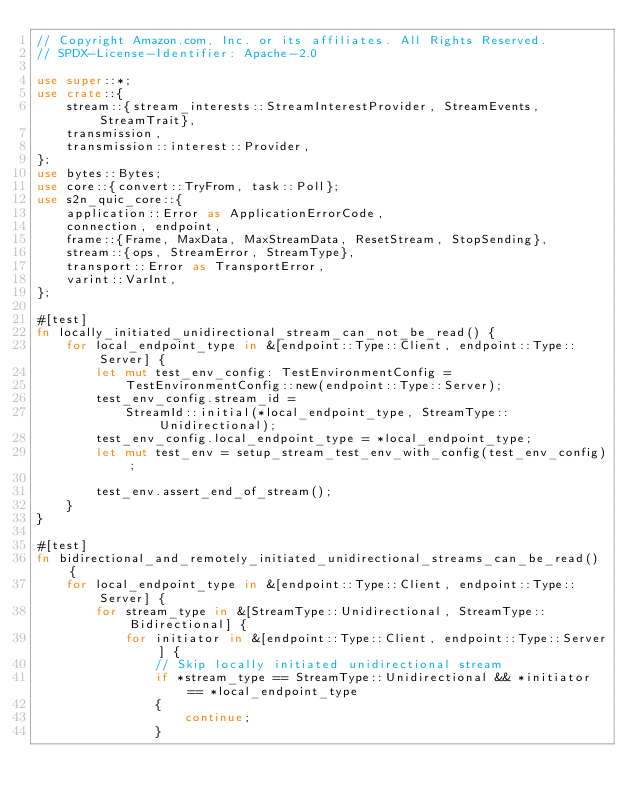<code> <loc_0><loc_0><loc_500><loc_500><_Rust_>// Copyright Amazon.com, Inc. or its affiliates. All Rights Reserved.
// SPDX-License-Identifier: Apache-2.0

use super::*;
use crate::{
    stream::{stream_interests::StreamInterestProvider, StreamEvents, StreamTrait},
    transmission,
    transmission::interest::Provider,
};
use bytes::Bytes;
use core::{convert::TryFrom, task::Poll};
use s2n_quic_core::{
    application::Error as ApplicationErrorCode,
    connection, endpoint,
    frame::{Frame, MaxData, MaxStreamData, ResetStream, StopSending},
    stream::{ops, StreamError, StreamType},
    transport::Error as TransportError,
    varint::VarInt,
};

#[test]
fn locally_initiated_unidirectional_stream_can_not_be_read() {
    for local_endpoint_type in &[endpoint::Type::Client, endpoint::Type::Server] {
        let mut test_env_config: TestEnvironmentConfig =
            TestEnvironmentConfig::new(endpoint::Type::Server);
        test_env_config.stream_id =
            StreamId::initial(*local_endpoint_type, StreamType::Unidirectional);
        test_env_config.local_endpoint_type = *local_endpoint_type;
        let mut test_env = setup_stream_test_env_with_config(test_env_config);

        test_env.assert_end_of_stream();
    }
}

#[test]
fn bidirectional_and_remotely_initiated_unidirectional_streams_can_be_read() {
    for local_endpoint_type in &[endpoint::Type::Client, endpoint::Type::Server] {
        for stream_type in &[StreamType::Unidirectional, StreamType::Bidirectional] {
            for initiator in &[endpoint::Type::Client, endpoint::Type::Server] {
                // Skip locally initiated unidirectional stream
                if *stream_type == StreamType::Unidirectional && *initiator == *local_endpoint_type
                {
                    continue;
                }
</code> 